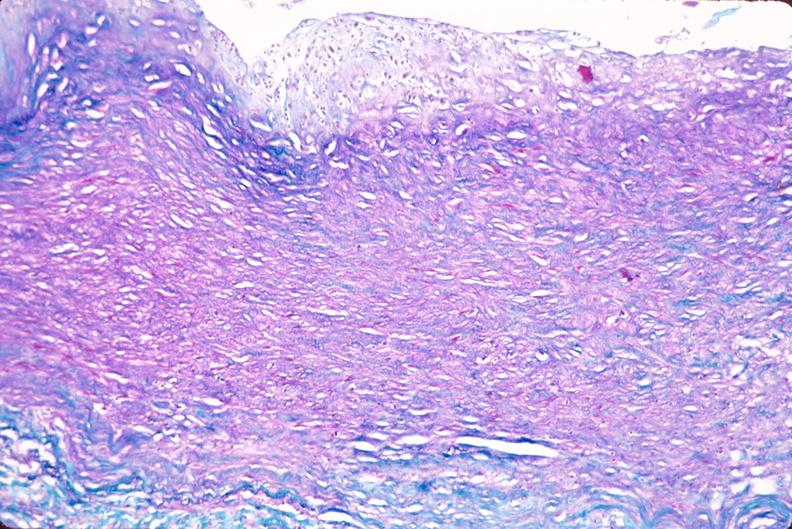does lesion of myocytolysis show saphenous vein graft sclerosis?
Answer the question using a single word or phrase. No 